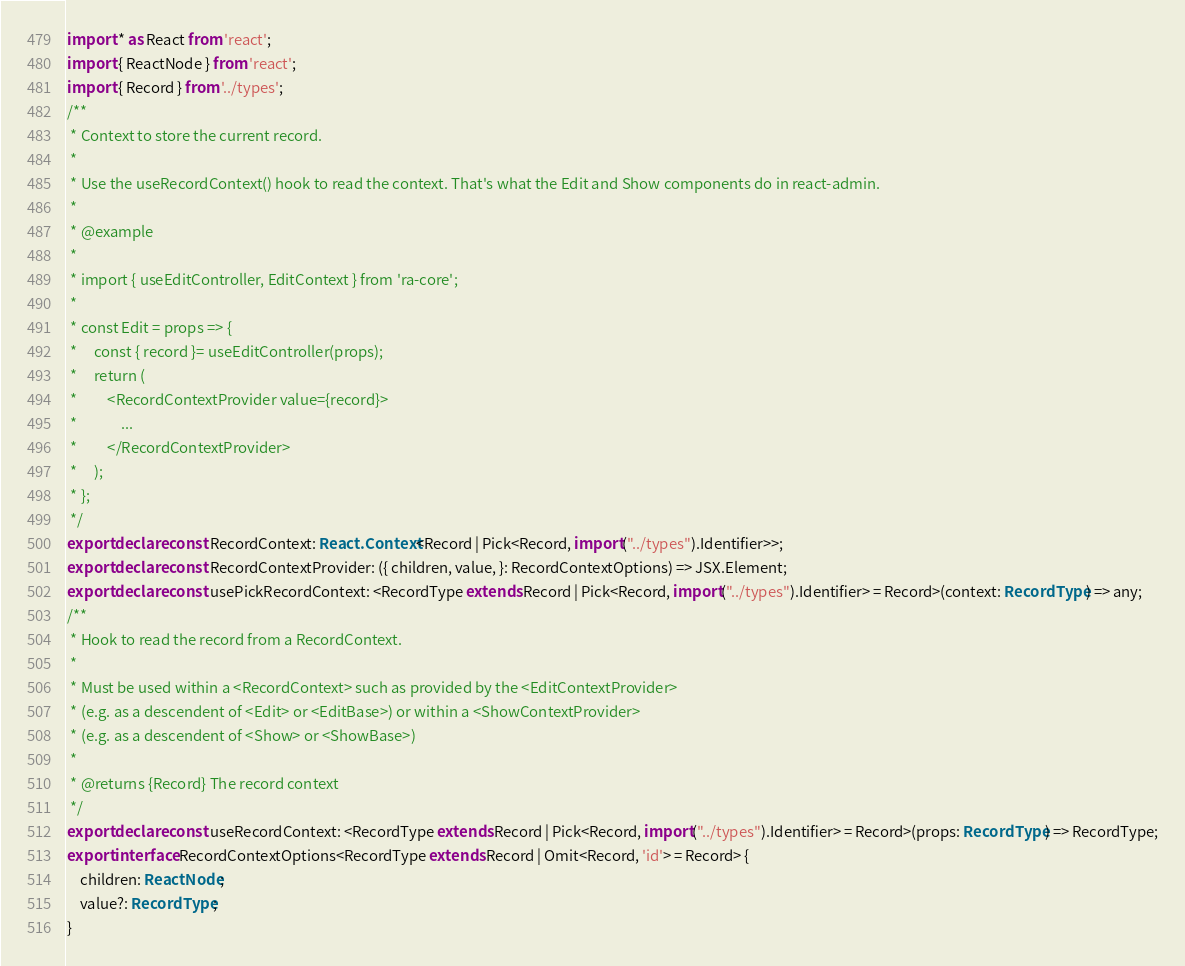Convert code to text. <code><loc_0><loc_0><loc_500><loc_500><_TypeScript_>import * as React from 'react';
import { ReactNode } from 'react';
import { Record } from '../types';
/**
 * Context to store the current record.
 *
 * Use the useRecordContext() hook to read the context. That's what the Edit and Show components do in react-admin.
 *
 * @example
 *
 * import { useEditController, EditContext } from 'ra-core';
 *
 * const Edit = props => {
 *     const { record }= useEditController(props);
 *     return (
 *         <RecordContextProvider value={record}>
 *             ...
 *         </RecordContextProvider>
 *     );
 * };
 */
export declare const RecordContext: React.Context<Record | Pick<Record, import("../types").Identifier>>;
export declare const RecordContextProvider: ({ children, value, }: RecordContextOptions) => JSX.Element;
export declare const usePickRecordContext: <RecordType extends Record | Pick<Record, import("../types").Identifier> = Record>(context: RecordType) => any;
/**
 * Hook to read the record from a RecordContext.
 *
 * Must be used within a <RecordContext> such as provided by the <EditContextProvider>
 * (e.g. as a descendent of <Edit> or <EditBase>) or within a <ShowContextProvider>
 * (e.g. as a descendent of <Show> or <ShowBase>)
 *
 * @returns {Record} The record context
 */
export declare const useRecordContext: <RecordType extends Record | Pick<Record, import("../types").Identifier> = Record>(props: RecordType) => RecordType;
export interface RecordContextOptions<RecordType extends Record | Omit<Record, 'id'> = Record> {
    children: ReactNode;
    value?: RecordType;
}
</code> 